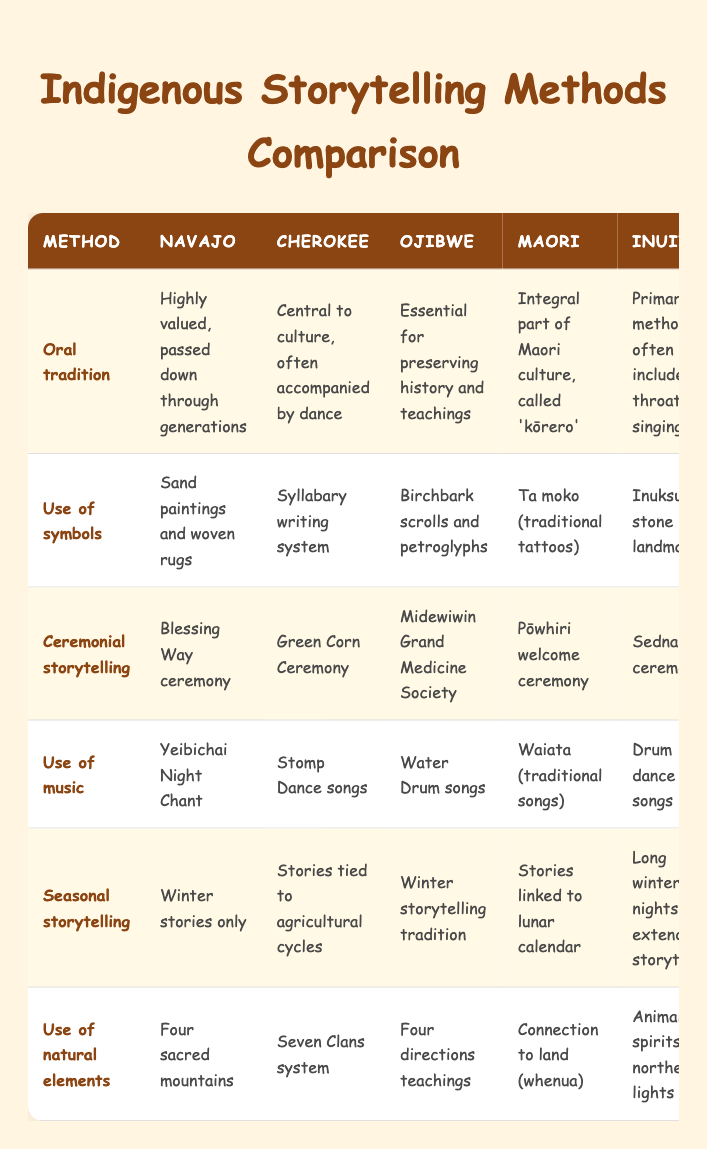What storytelling method is used by the Ojibwe? The table shows that the Ojibwe use "Oral tradition," which is essential for preserving history and teachings.
Answer: Oral tradition Which tribe's storytelling method includes throat singing? The table indicates that the Inuit have throat singing as part of their oral tradition storytelling method.
Answer: Inuit Do the Cherokee use symbols in their storytelling? Yes, based on the table, the Cherokee storytelling method includes a syllabary writing system.
Answer: Yes What is the ceremonial storytelling method used by the Navajo? According to the table, the Navajo use the "Blessing Way ceremony" for ceremonial storytelling.
Answer: Blessing Way ceremony Which tribe has a storytelling tradition tied to the lunar calendar? The table reveals that the Maori link their storytelling to the lunar calendar, making it their specific tradition.
Answer: Maori How many storytelling methods are listed for the Inuit tribe? There are five storytelling methods listed in the table, and all five mention methods used by the Inuit.
Answer: Five Which tribe's use of natural elements mentions the connection to land? The table indicates that the Maori tribe's storytelling includes a connection to the land, referred to as "whenua."
Answer: Maori Are the stories of the Cherokee linked to agricultural cycles? Yes, the table confirms that the Cherokee storytelling is tied to agricultural cycles.
Answer: Yes What is the primary storytelling method for the Navajo and how does it compare to that of the Inuit? The Navajo's primary storytelling method is oral tradition, which is highly valued and passed down. The Inuit's primary method also involves oral tradition but includes throat singing. This shows that both tribes value oral traditions, but the Inuit incorporate unique musical elements.
Answer: Both use oral tradition, but the Inuit include throat singing 